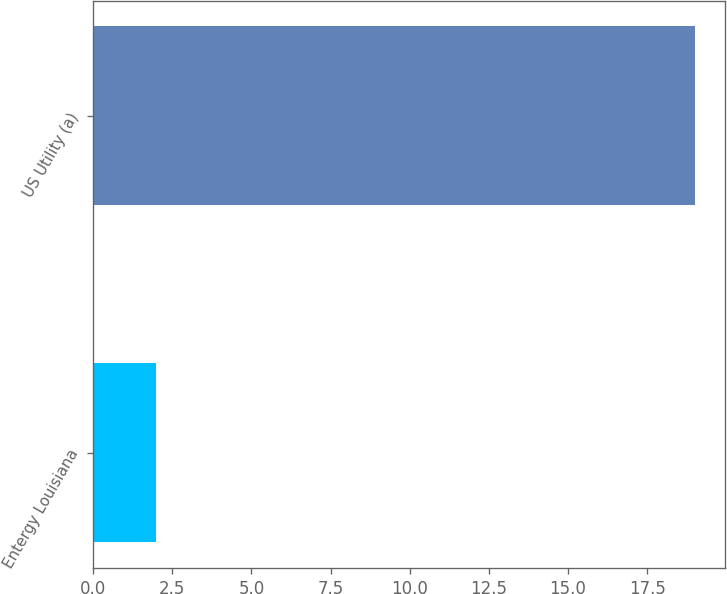<chart> <loc_0><loc_0><loc_500><loc_500><bar_chart><fcel>Entergy Louisiana<fcel>US Utility (a)<nl><fcel>2<fcel>19<nl></chart> 